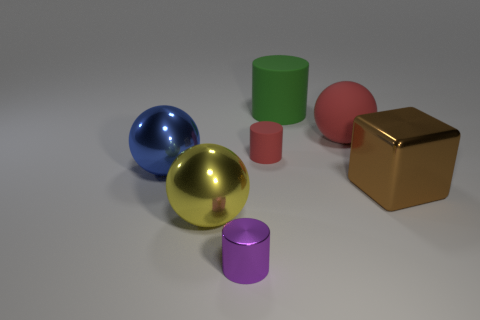There is a red matte object that is in front of the red rubber ball; is there a tiny red rubber thing on the left side of it? Correct, there is no tiny red rubber object on the left side of the red matte item, which appears to be a cylinder. Instead, to the left, there is a violet-colored cylinder, smaller in size than both the red objects in view. 